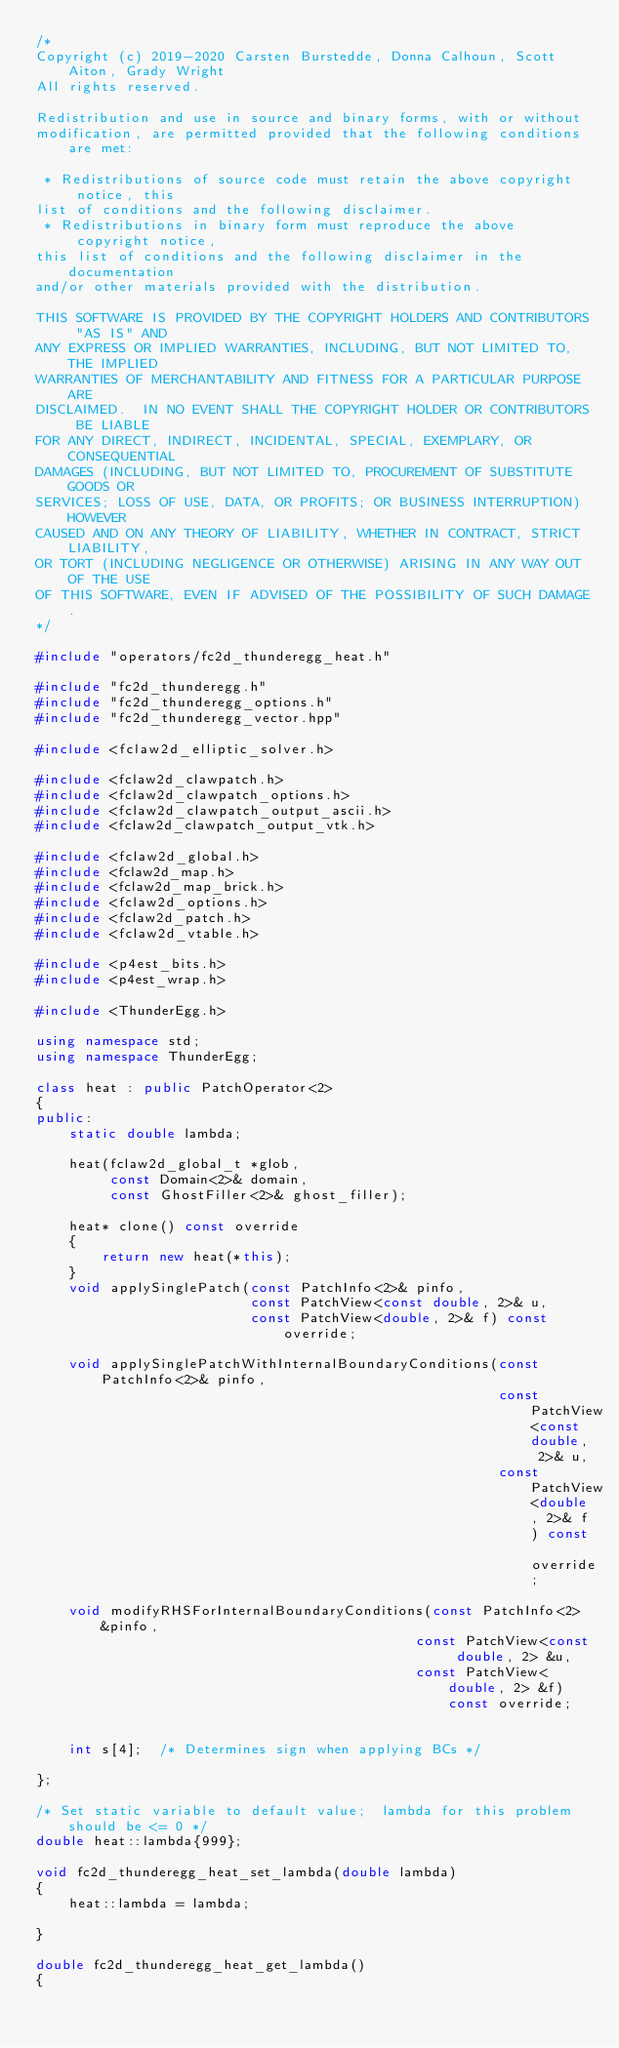Convert code to text. <code><loc_0><loc_0><loc_500><loc_500><_C++_>/*
Copyright (c) 2019-2020 Carsten Burstedde, Donna Calhoun, Scott Aiton, Grady Wright
All rights reserved.

Redistribution and use in source and binary forms, with or without
modification, are permitted provided that the following conditions are met:

 * Redistributions of source code must retain the above copyright notice, this
list of conditions and the following disclaimer.
 * Redistributions in binary form must reproduce the above copyright notice,
this list of conditions and the following disclaimer in the documentation
and/or other materials provided with the distribution.

THIS SOFTWARE IS PROVIDED BY THE COPYRIGHT HOLDERS AND CONTRIBUTORS "AS IS" AND
ANY EXPRESS OR IMPLIED WARRANTIES, INCLUDING, BUT NOT LIMITED TO, THE IMPLIED
WARRANTIES OF MERCHANTABILITY AND FITNESS FOR A PARTICULAR PURPOSE ARE
DISCLAIMED.  IN NO EVENT SHALL THE COPYRIGHT HOLDER OR CONTRIBUTORS BE LIABLE
FOR ANY DIRECT, INDIRECT, INCIDENTAL, SPECIAL, EXEMPLARY, OR CONSEQUENTIAL
DAMAGES (INCLUDING, BUT NOT LIMITED TO, PROCUREMENT OF SUBSTITUTE GOODS OR
SERVICES; LOSS OF USE, DATA, OR PROFITS; OR BUSINESS INTERRUPTION) HOWEVER
CAUSED AND ON ANY THEORY OF LIABILITY, WHETHER IN CONTRACT, STRICT LIABILITY,
OR TORT (INCLUDING NEGLIGENCE OR OTHERWISE) ARISING IN ANY WAY OUT OF THE USE
OF THIS SOFTWARE, EVEN IF ADVISED OF THE POSSIBILITY OF SUCH DAMAGE.
*/

#include "operators/fc2d_thunderegg_heat.h"

#include "fc2d_thunderegg.h"
#include "fc2d_thunderegg_options.h"
#include "fc2d_thunderegg_vector.hpp"

#include <fclaw2d_elliptic_solver.h>

#include <fclaw2d_clawpatch.h>
#include <fclaw2d_clawpatch_options.h>
#include <fclaw2d_clawpatch_output_ascii.h>
#include <fclaw2d_clawpatch_output_vtk.h>

#include <fclaw2d_global.h>
#include <fclaw2d_map.h>
#include <fclaw2d_map_brick.h>
#include <fclaw2d_options.h>
#include <fclaw2d_patch.h>
#include <fclaw2d_vtable.h>

#include <p4est_bits.h>
#include <p4est_wrap.h>

#include <ThunderEgg.h>

using namespace std;
using namespace ThunderEgg;

class heat : public PatchOperator<2>
{
public:
    static double lambda;

    heat(fclaw2d_global_t *glob, 
         const Domain<2>& domain,
         const GhostFiller<2>& ghost_filler);

    heat* clone() const override
    {
        return new heat(*this);
    }
    void applySinglePatch(const PatchInfo<2>& pinfo,
                          const PatchView<const double, 2>& u,
                          const PatchView<double, 2>& f) const override;

    void applySinglePatchWithInternalBoundaryConditions(const PatchInfo<2>& pinfo,
                                                        const PatchView<const double, 2>& u,
                                                        const PatchView<double, 2>& f) const override;

    void modifyRHSForInternalBoundaryConditions(const PatchInfo<2> &pinfo,
	                                            const PatchView<const double, 2> &u,
	                                            const PatchView<double, 2> &f) const override;


    int s[4];  /* Determines sign when applying BCs */

};

/* Set static variable to default value;  lambda for this problem should be <= 0 */
double heat::lambda{999};

void fc2d_thunderegg_heat_set_lambda(double lambda)
{
    heat::lambda = lambda;

}

double fc2d_thunderegg_heat_get_lambda()
{</code> 